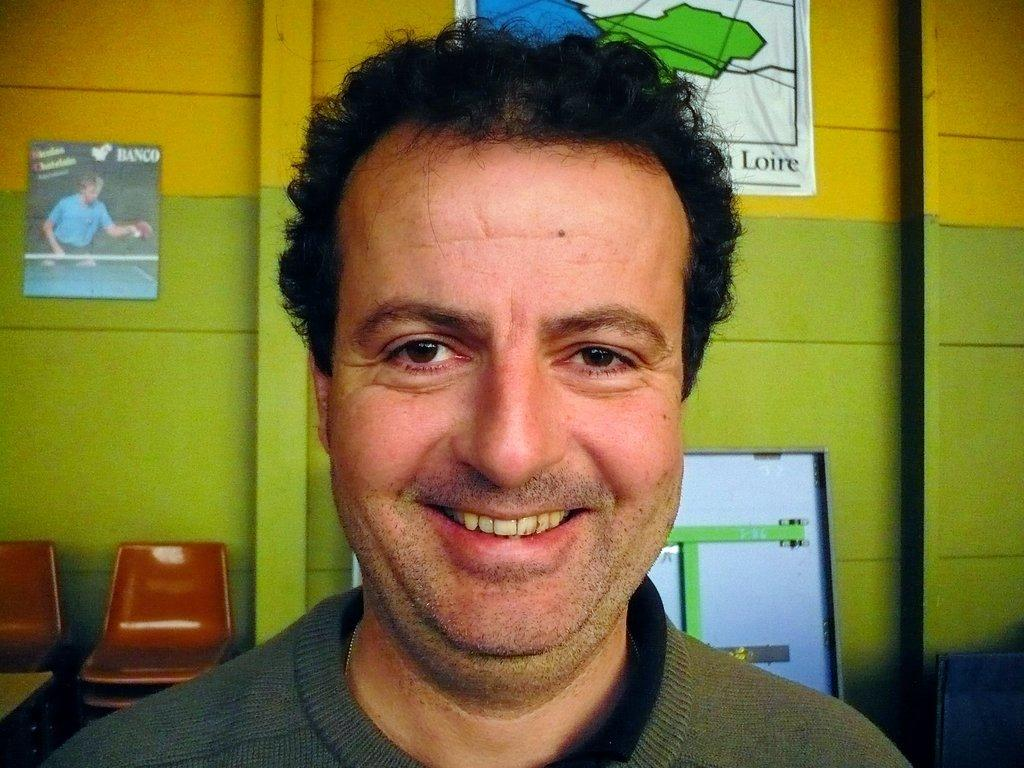Who is present in the image? There is a man in the image. What can be seen on the wall in the image? There are pictures on a wall in the image. What architectural feature is visible in the image? There is a door in the image. What type of furniture is present in the image? There are empty chairs in the image. What type of plastic is covering the bat in the image? There is no bat or plastic present in the image. 